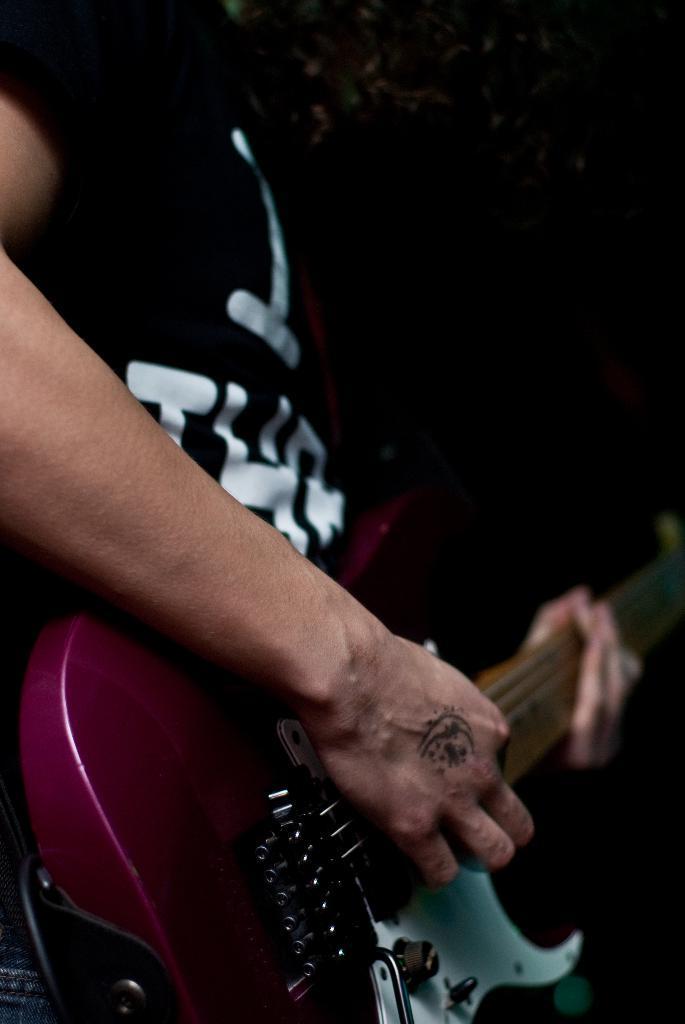How would you summarize this image in a sentence or two? In this image we can see a person playing a musical instrument. The background of the image is dark. 